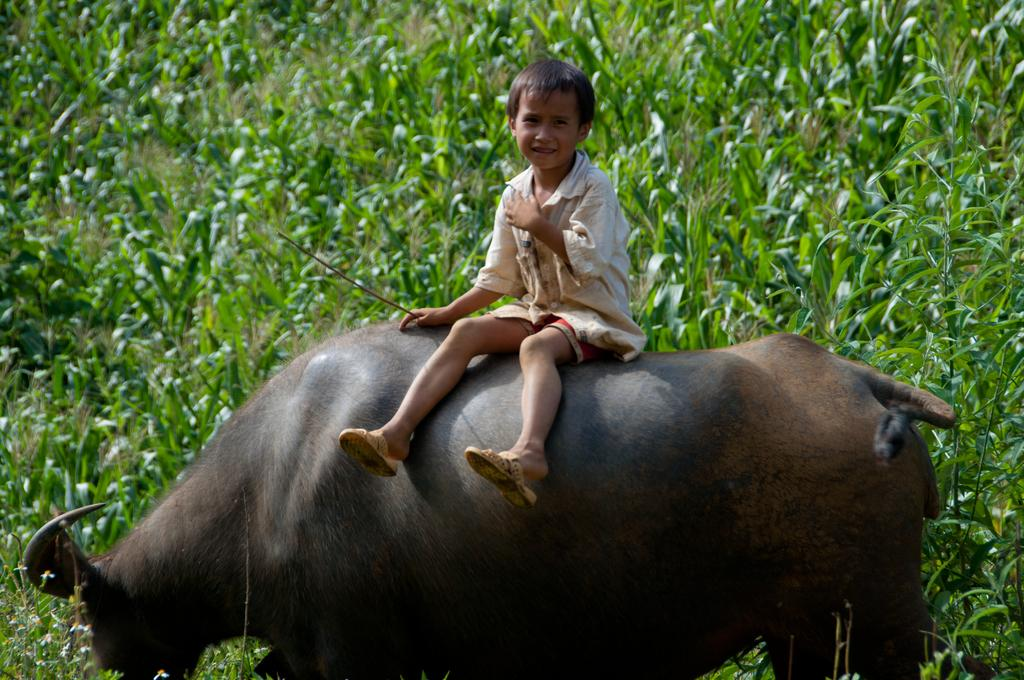What is the main setting of the image? The image depicts a grass field. Who is present in the image? There is a boy in the image. What is the boy doing in the image? The boy is sitting on a buffalo. What is the boy's facial expression in the image? The boy is smiling. What object is the boy holding in the image? The boy is holding a stick. What time of day is it in the image, and is the boy crying? The time of day is not mentioned in the image, and the boy is not crying; he is smiling. 